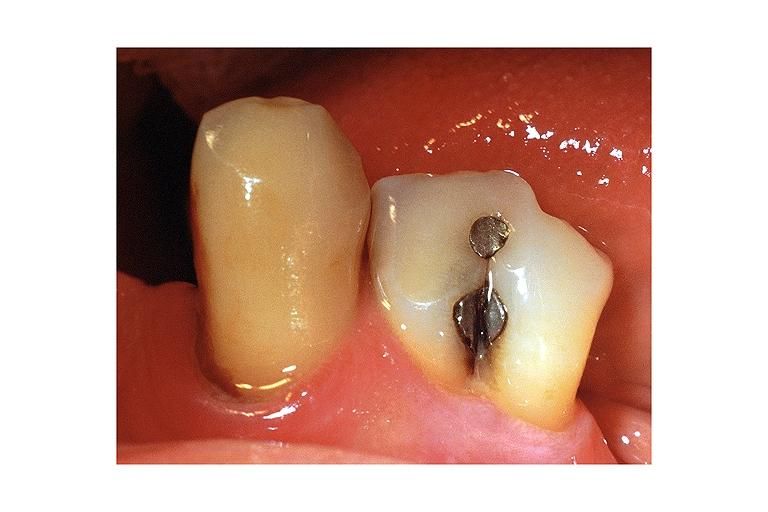s oral present?
Answer the question using a single word or phrase. Yes 